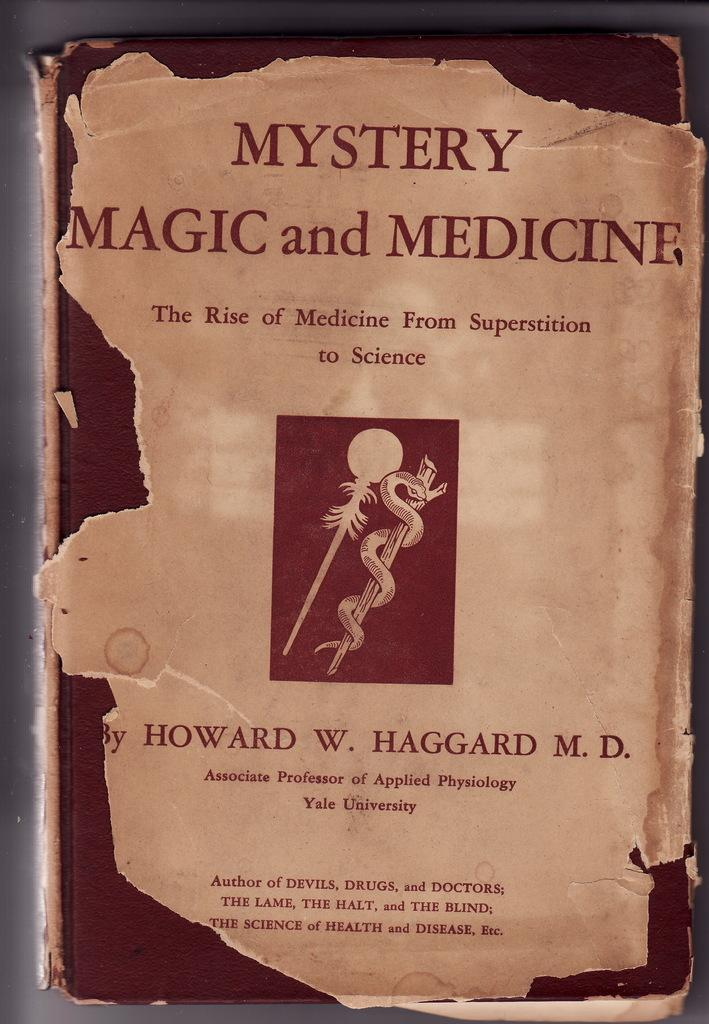<image>
Relay a brief, clear account of the picture shown. An old battered book titled Mystery Magic and Medicine. 